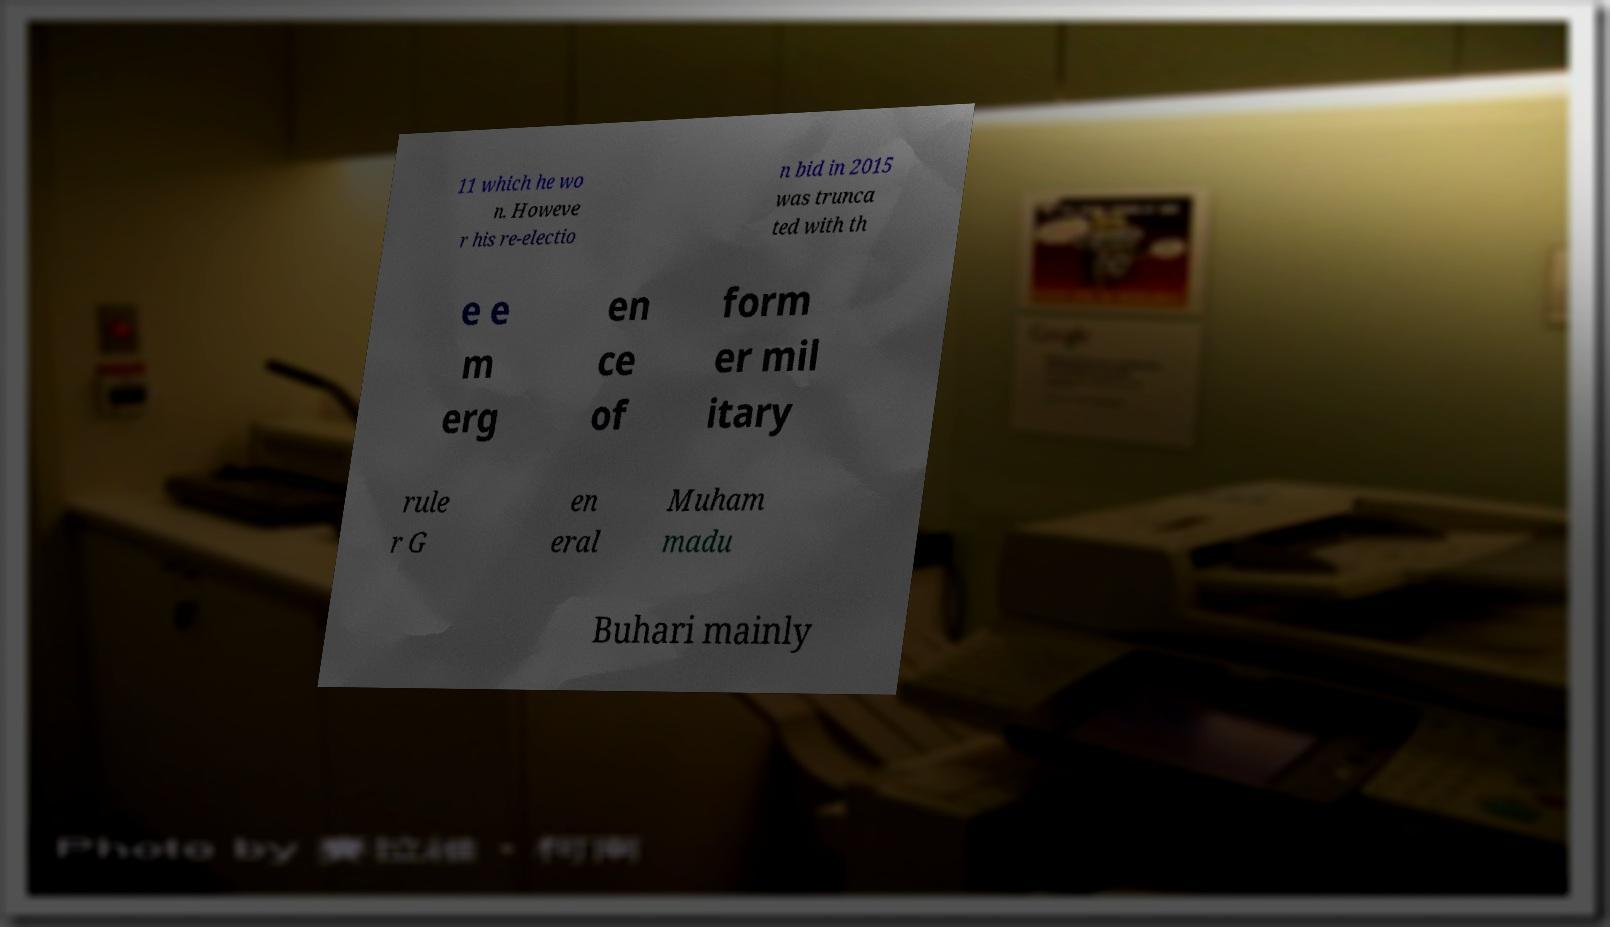Can you accurately transcribe the text from the provided image for me? 11 which he wo n. Howeve r his re-electio n bid in 2015 was trunca ted with th e e m erg en ce of form er mil itary rule r G en eral Muham madu Buhari mainly 